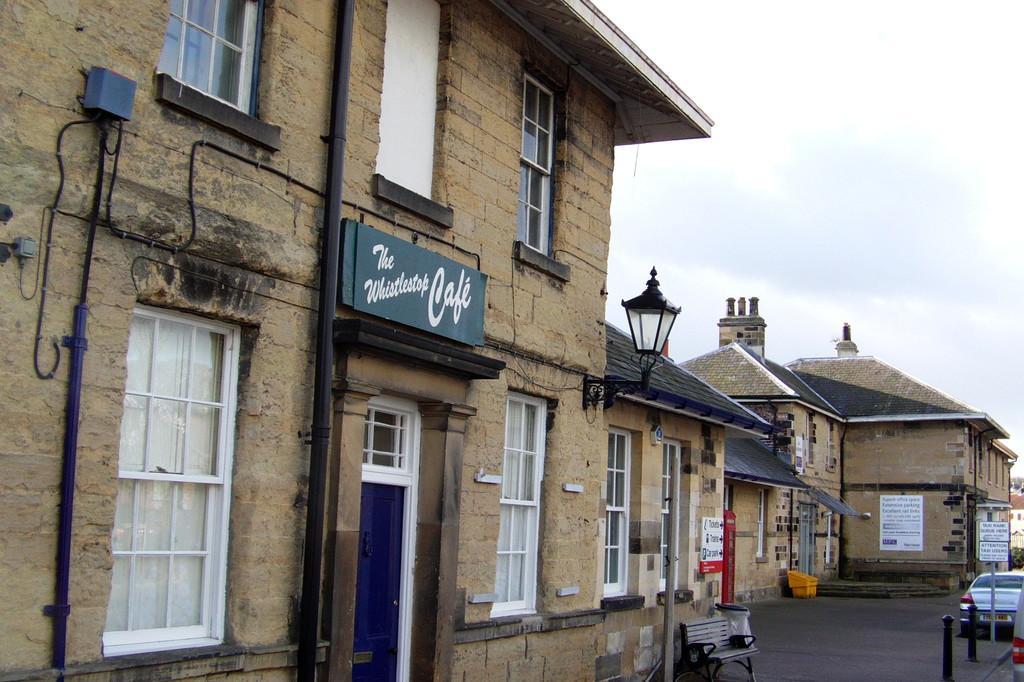How would you summarize this image in a sentence or two? This picture is clicked outside the city. In front of the picture, we see a building. It has windows and a door. We see a board in blue color with some text written on it. We even see the light. At the bottom, we see the road and a bench. In the bottom right, we see the poles and the cars are moving on the road. In the background, we see the buildings and an object in yellow color. In the top right, we see the sky. 